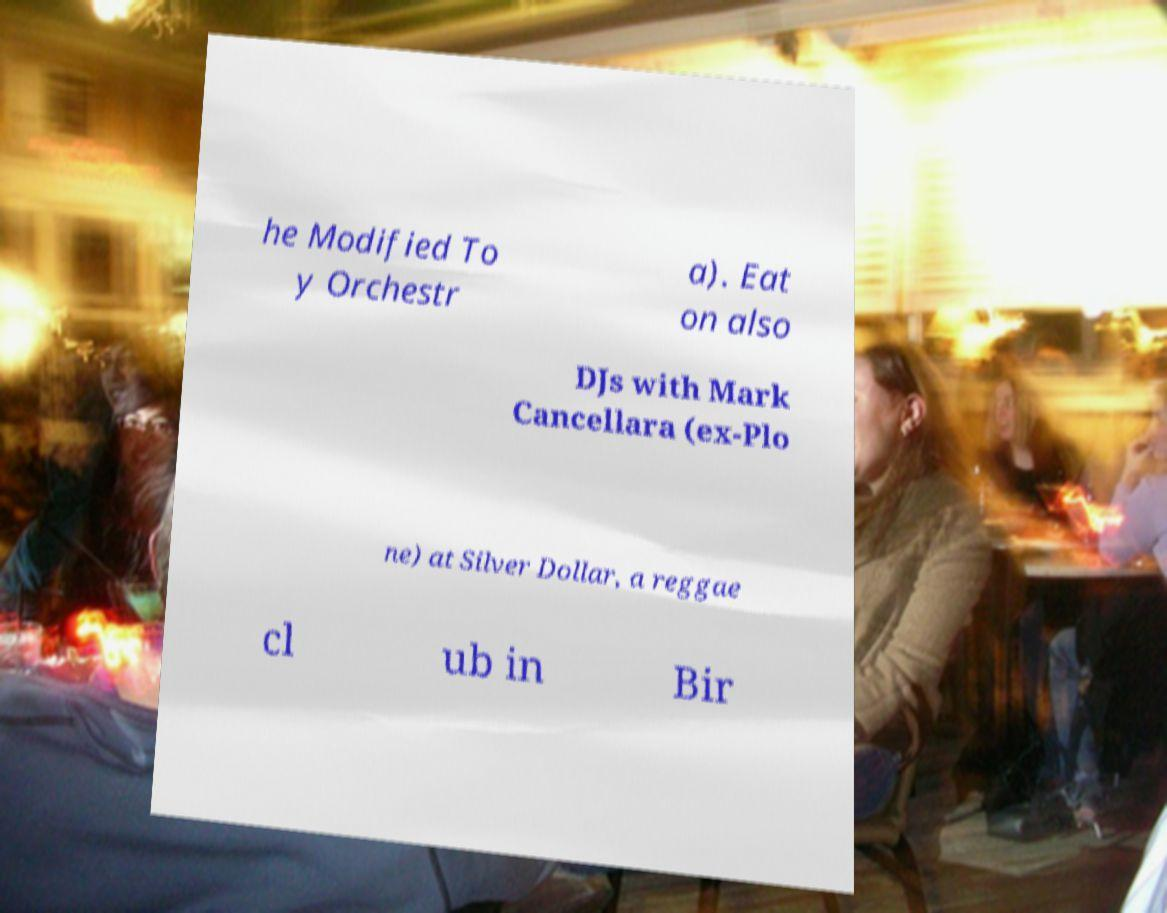Could you assist in decoding the text presented in this image and type it out clearly? he Modified To y Orchestr a). Eat on also DJs with Mark Cancellara (ex-Plo ne) at Silver Dollar, a reggae cl ub in Bir 